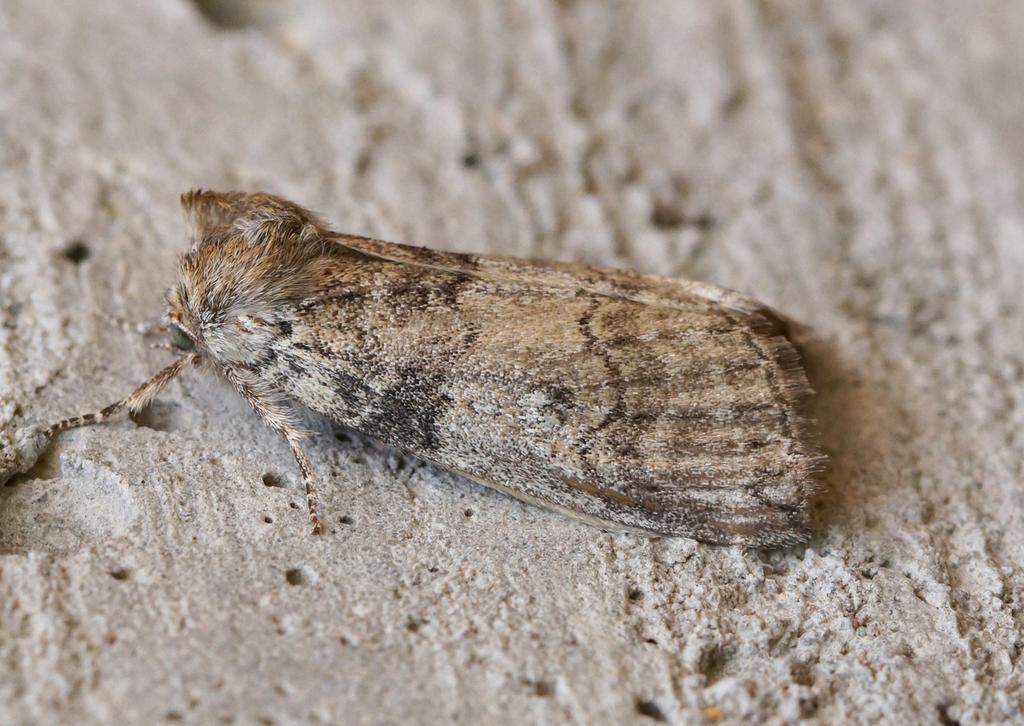In one or two sentences, can you explain what this image depicts? In this image in the foreground there is some kind of insect on the ground. 